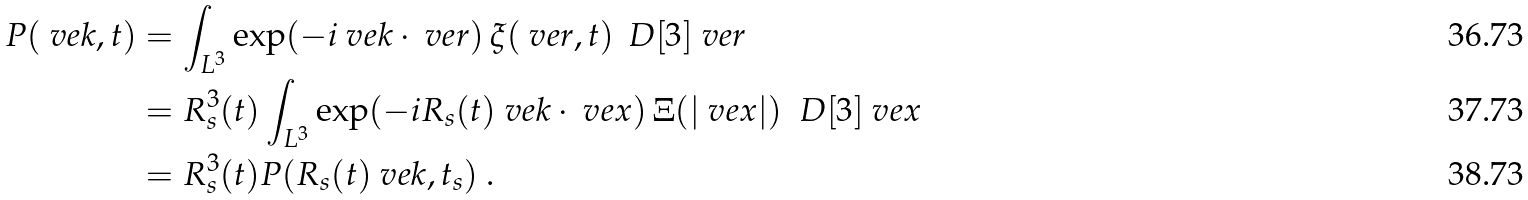Convert formula to latex. <formula><loc_0><loc_0><loc_500><loc_500>P ( \ v e k , t ) & = \int _ { L ^ { 3 } } \exp ( - i \ v e k \cdot \ v e r ) \, { \xi } ( \ v e r , t ) \, \ D [ 3 ] \ v e r \\ & = R _ { s } ^ { 3 } ( t ) \int _ { L ^ { 3 } } \exp ( - i R _ { s } ( t ) \ v e k \cdot \ v e x ) \, \Xi ( | \ v e x | ) \ \ D [ 3 ] \ v e x \\ & = R _ { s } ^ { 3 } ( t ) P ( R _ { s } ( t ) \ v e k , t _ { s } ) \ .</formula> 